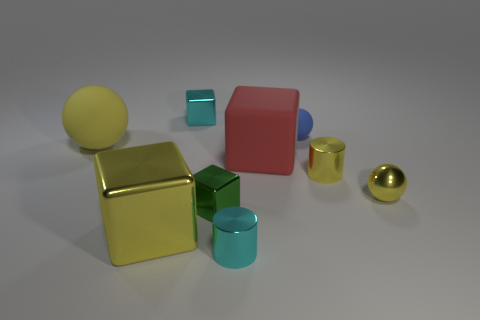Is there a yellow shiny thing of the same shape as the small blue thing?
Your answer should be compact. Yes. Do the red object and the object behind the blue rubber ball have the same shape?
Give a very brief answer. Yes. There is a yellow thing that is on the left side of the large red block and in front of the matte cube; what is its size?
Your answer should be very brief. Large. How many rubber cubes are there?
Keep it short and to the point. 1. There is a green object that is the same size as the yellow cylinder; what material is it?
Ensure brevity in your answer.  Metal. Are there any yellow shiny balls of the same size as the green block?
Offer a very short reply. Yes. Is the color of the small cylinder behind the big yellow metallic block the same as the small shiny block that is in front of the large yellow matte ball?
Give a very brief answer. No. What number of rubber objects are either cyan cylinders or small yellow cylinders?
Keep it short and to the point. 0. How many tiny cyan metallic objects are behind the metallic cube that is on the right side of the small shiny object that is behind the tiny blue rubber ball?
Ensure brevity in your answer.  1. What is the size of the yellow ball that is the same material as the blue ball?
Provide a short and direct response. Large. 